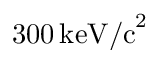Convert formula to latex. <formula><loc_0><loc_0><loc_500><loc_500>3 0 0 \, k e V / c ^ { 2 }</formula> 